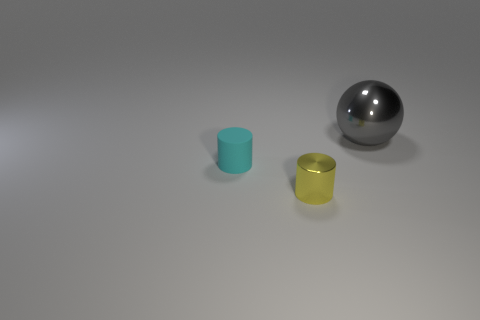Add 1 small green metal cylinders. How many objects exist? 4 Subtract all cylinders. How many objects are left? 1 Subtract 0 cyan balls. How many objects are left? 3 Subtract all red matte things. Subtract all large balls. How many objects are left? 2 Add 3 small rubber cylinders. How many small rubber cylinders are left? 4 Add 1 green metal objects. How many green metal objects exist? 1 